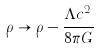<formula> <loc_0><loc_0><loc_500><loc_500>\rho \rightarrow \rho - { \frac { \Lambda c ^ { 2 } } { 8 \pi G } }</formula> 